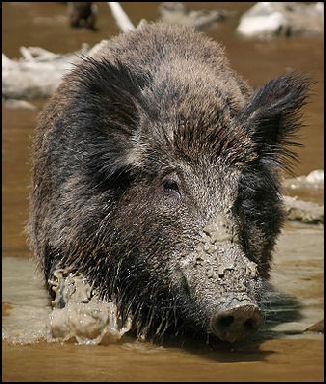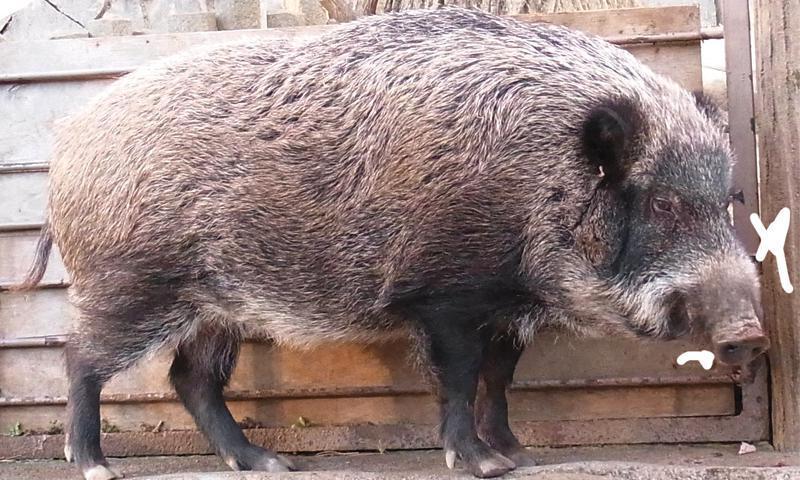The first image is the image on the left, the second image is the image on the right. Examine the images to the left and right. Is the description "A single animal is standing on the ground in the image on the right." accurate? Answer yes or no. Yes. 